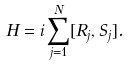Convert formula to latex. <formula><loc_0><loc_0><loc_500><loc_500>H = i \sum _ { j = 1 } ^ { N } [ R _ { j } , S _ { j } ] .</formula> 